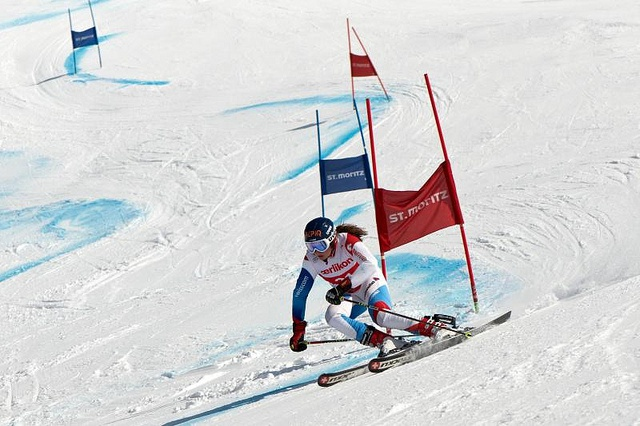Describe the objects in this image and their specific colors. I can see people in white, black, lightgray, darkgray, and maroon tones and skis in white, darkgray, gray, black, and lightgray tones in this image. 